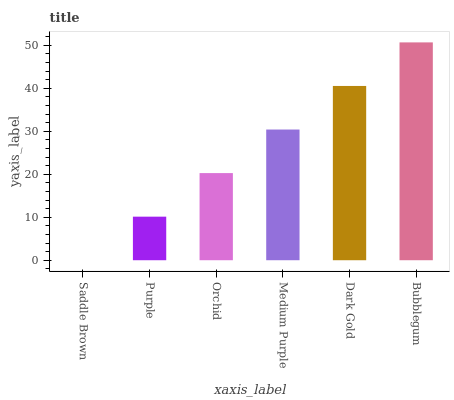Is Saddle Brown the minimum?
Answer yes or no. Yes. Is Bubblegum the maximum?
Answer yes or no. Yes. Is Purple the minimum?
Answer yes or no. No. Is Purple the maximum?
Answer yes or no. No. Is Purple greater than Saddle Brown?
Answer yes or no. Yes. Is Saddle Brown less than Purple?
Answer yes or no. Yes. Is Saddle Brown greater than Purple?
Answer yes or no. No. Is Purple less than Saddle Brown?
Answer yes or no. No. Is Medium Purple the high median?
Answer yes or no. Yes. Is Orchid the low median?
Answer yes or no. Yes. Is Purple the high median?
Answer yes or no. No. Is Bubblegum the low median?
Answer yes or no. No. 